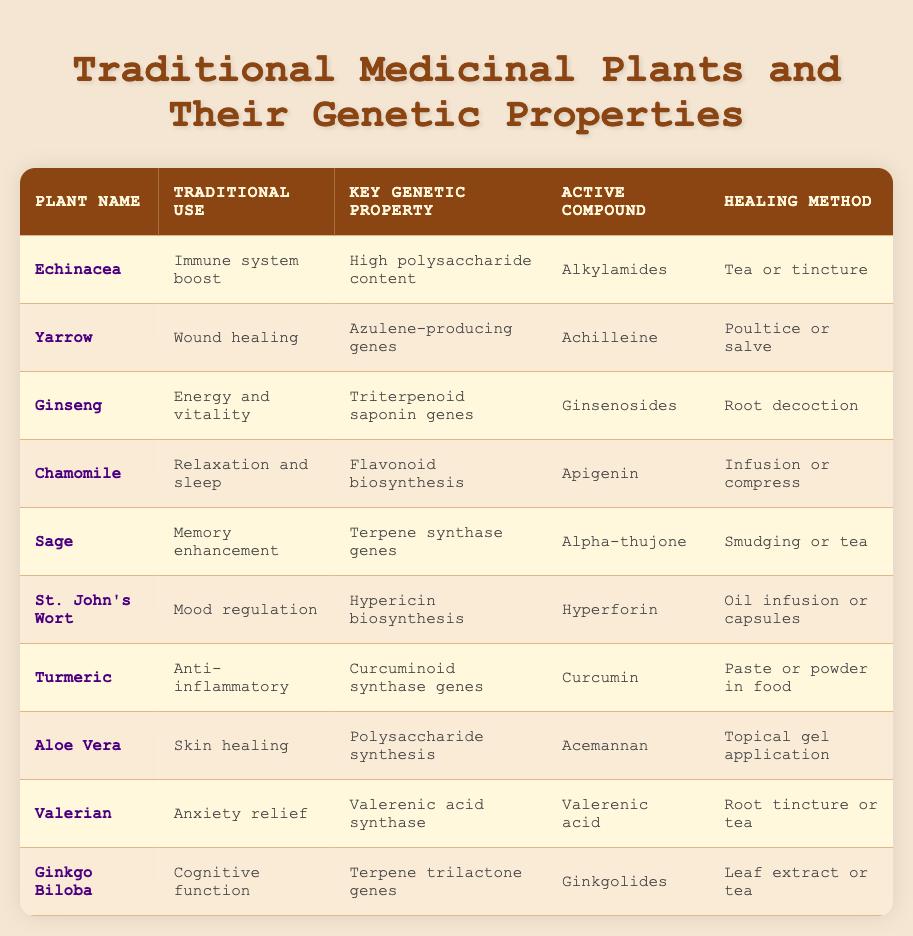What is the traditional use of Turmeric? The traditional use of Turmeric is stated in the table as "Anti-inflammatory." This can be found in the second column that lists the traditional uses of each plant.
Answer: Anti-inflammatory Which plant is used for anxiety relief? The table indicates that Valerian is used for anxiety relief, as it is listed in the traditional use column next to the name Valerian.
Answer: Valerian How many plants have a key genetic property related to polysaccharides? There are two plants with key genetic properties related to polysaccharides: Echinacea (High polysaccharide content) and Aloe Vera (Polysaccharide synthesis). The process involves identifying these two entries in the key genetic property column.
Answer: 2 Is Ginkgo Biloba associated with mood regulation? According to the table, Ginkgo Biloba is associated with cognitive function and not mood regulation (which is associated with St. John's Wort). Therefore, the statement is false.
Answer: No Which plant's active compound is hyperforin? The table shows that the active compound hyperforin is associated with St. John's Wort, as indicated in the active compound column.
Answer: St. John's Wort What is the healing method for Chamomile? The healing method for Chamomile is listed in the table as "Infusion or compress." This can be found in the last column of the respective row for Chamomile.
Answer: Infusion or compress Which plant has the highest number of steps to reach its healing method based on the data? To determine this, we need to analyze the entries. Several plants have a straightforward application method like "tea" or "salve," but others like Ginseng requires a root decoction. However, this does not have multiple steps. Since none provide a multi-step method explicitly, it can be concluded that all are direct applications.
Answer: None List the active compounds for the plants that enhance memory. The table states that the active compound for Sage is Alpha-thujone, and it does not list another plant specifically enhancing memory. Therefore, the answer is directly tied to Sage’s entry in the active compound column.
Answer: Alpha-thujone Is it true that Echinacea is primarily used for relaxation? The table indicates Echinacea is used for immune system boost, not relaxation (which is the traditional use for Chamomile). Thus, the statement is false.
Answer: No 